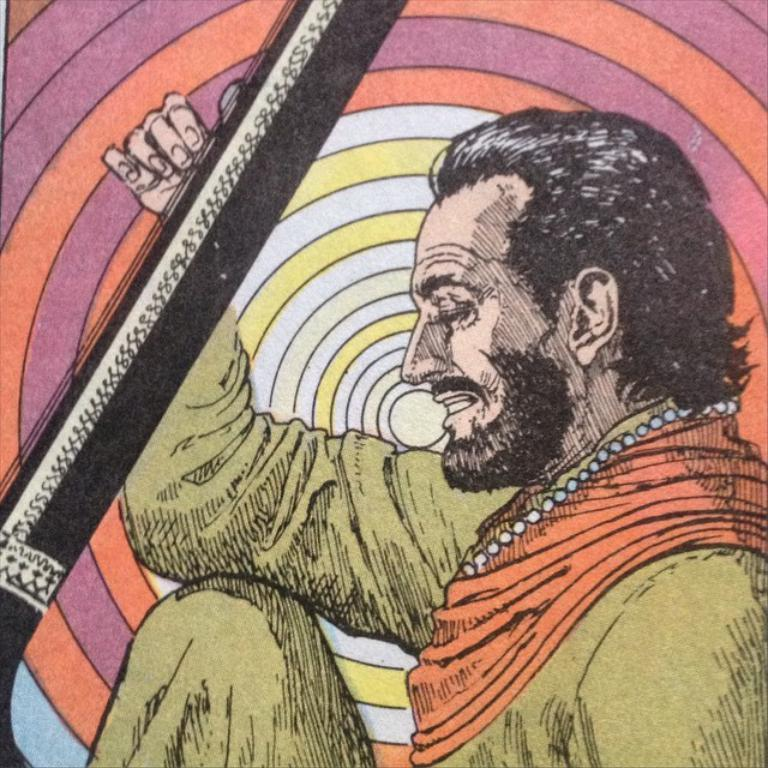What is the main subject of the image? The main subject of the image is a sketch of a person. Can you describe the background of the image? The background of the image is colorful. What is the person in the sketch doing? The person in the sketch is playing a musical instrument. What type of milk is being offered by the person in the sketch? There is no milk or offering present in the image; it features a sketch of a person playing a musical instrument. 